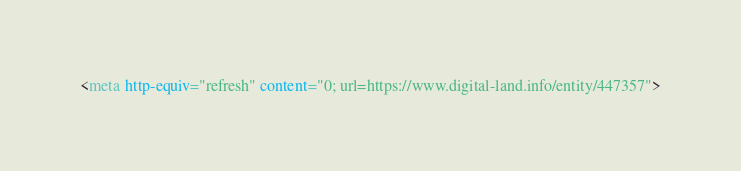Convert code to text. <code><loc_0><loc_0><loc_500><loc_500><_HTML_><meta http-equiv="refresh" content="0; url=https://www.digital-land.info/entity/447357"></code> 